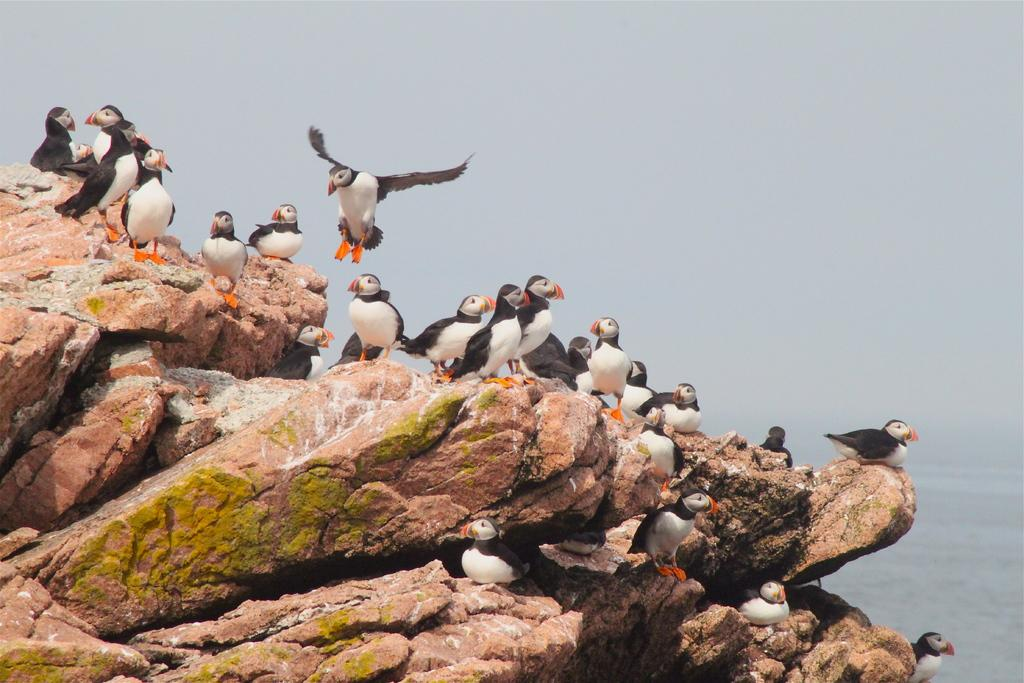What are the birds doing in the image? There are birds sitting on a rock in the image, and one bird is flying. What can be seen in the background of the image? There is water visible in the image. What is the condition of the sky in the image? The sky is cloudy in the image. What type of lumber is being used to build the nest in the image? There is no nest present in the image, so it is not possible to determine what type of lumber might be used. What is the level of pain experienced by the birds in the image? There is no indication of pain in the image, as the birds are either sitting or flying. 